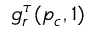<formula> <loc_0><loc_0><loc_500><loc_500>g _ { r } ^ { \tau } ( p _ { c } , 1 )</formula> 